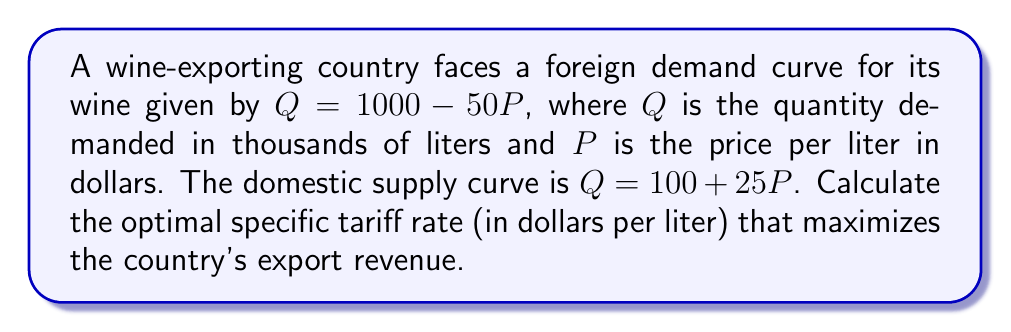Can you answer this question? 1) First, we need to find the export supply curve. This is the difference between domestic supply and demand:
   $Q_E = (100 + 25P) - (1000 - 50P) = 75P - 900$

2) The inverse export supply curve is:
   $P = \frac{Q_E + 900}{75}$

3) The foreign demand curve in inverse form is:
   $P = 20 - \frac{Q}{50}$

4) With a tariff $t$, the price paid by foreign consumers is:
   $P_f = 20 - \frac{Q}{50}$
   And the price received by domestic producers is:
   $P_d = \frac{Q + 900}{75}$
   The difference is the tariff:
   $t = P_f - P_d = 20 - \frac{Q}{50} - \frac{Q + 900}{75}$

5) Export revenue is price times quantity:
   $R = Q \cdot P_d = Q \cdot (\frac{Q + 900}{75})$

6) To maximize revenue, we differentiate with respect to Q and set to zero:
   $\frac{dR}{dQ} = \frac{Q + 900}{75} + Q \cdot \frac{1}{75} = \frac{2Q + 900}{75} = 0$

7) Solving this equation:
   $2Q + 900 = 0$
   $Q = -450$

8) The optimal quantity is 450,000 liters (note the negative sign is because we're exporting).

9) Substituting this back into the tariff equation:
   $t = 20 - \frac{450}{50} - \frac{450 + 900}{75} = 20 - 9 - 18 = -7$

10) The negative sign indicates that this is actually an export subsidy, not a tariff.
Answer: $7 per liter (export subsidy) 